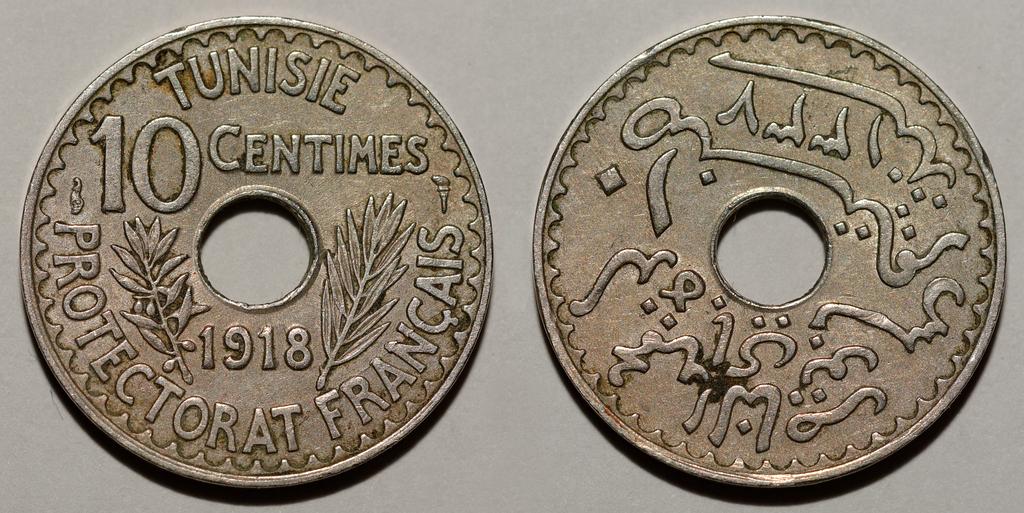What word is on the top of the coin on the left?
Make the answer very short. Tunisie. When was this coin made?
Ensure brevity in your answer.  1918. 